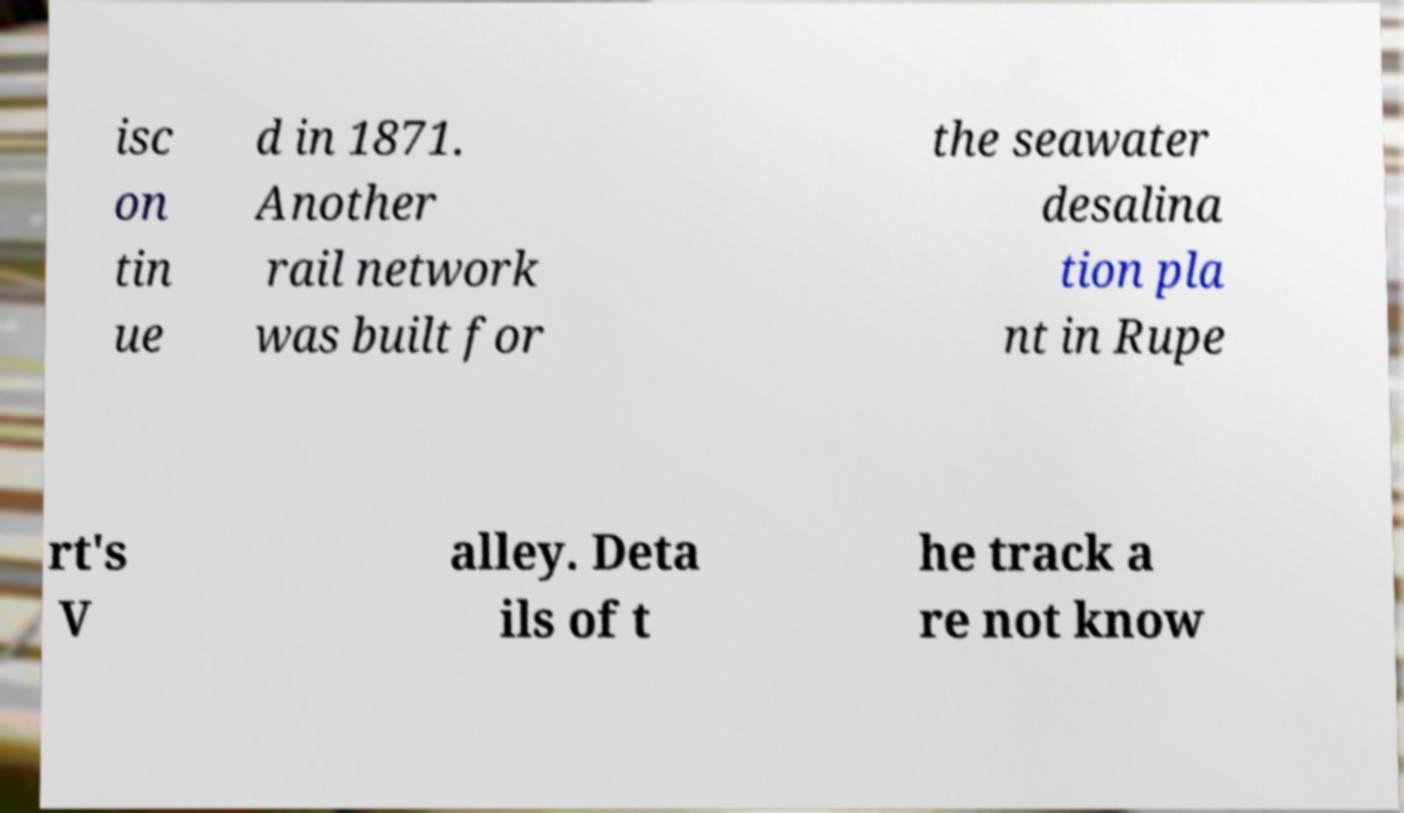Please identify and transcribe the text found in this image. isc on tin ue d in 1871. Another rail network was built for the seawater desalina tion pla nt in Rupe rt's V alley. Deta ils of t he track a re not know 